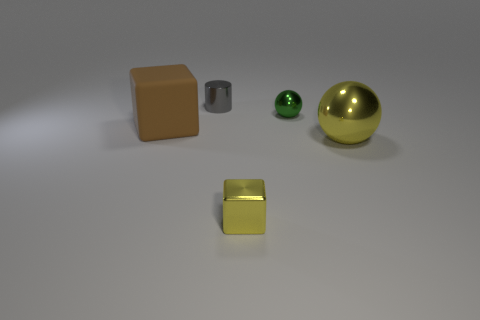Add 3 cubes. How many objects exist? 8 Subtract 1 cylinders. How many cylinders are left? 0 Subtract all green balls. How many brown cylinders are left? 0 Subtract all cyan rubber balls. Subtract all big yellow balls. How many objects are left? 4 Add 5 green metal objects. How many green metal objects are left? 6 Add 1 small brown balls. How many small brown balls exist? 1 Subtract 1 gray cylinders. How many objects are left? 4 Subtract all cylinders. How many objects are left? 4 Subtract all green cylinders. Subtract all green cubes. How many cylinders are left? 1 